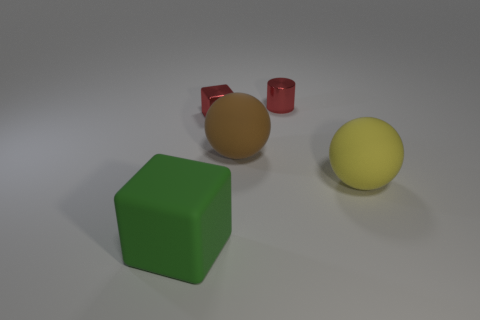Is the green cube to the left of the large yellow matte thing made of the same material as the red object in front of the small red cylinder?
Provide a succinct answer. No. How big is the red thing right of the shiny cube?
Your response must be concise. Small. The brown matte sphere has what size?
Offer a terse response. Large. What size is the matte object on the right side of the shiny thing behind the tiny metal object in front of the small red cylinder?
Keep it short and to the point. Large. Is there a cylinder made of the same material as the large block?
Your response must be concise. No. The big brown rubber object has what shape?
Provide a succinct answer. Sphere. The large sphere that is the same material as the yellow thing is what color?
Keep it short and to the point. Brown. How many yellow objects are metallic blocks or large blocks?
Provide a succinct answer. 0. Is the number of balls greater than the number of red metal cylinders?
Your answer should be very brief. Yes. How many objects are blocks behind the green cube or blocks that are right of the green matte object?
Offer a terse response. 1. 